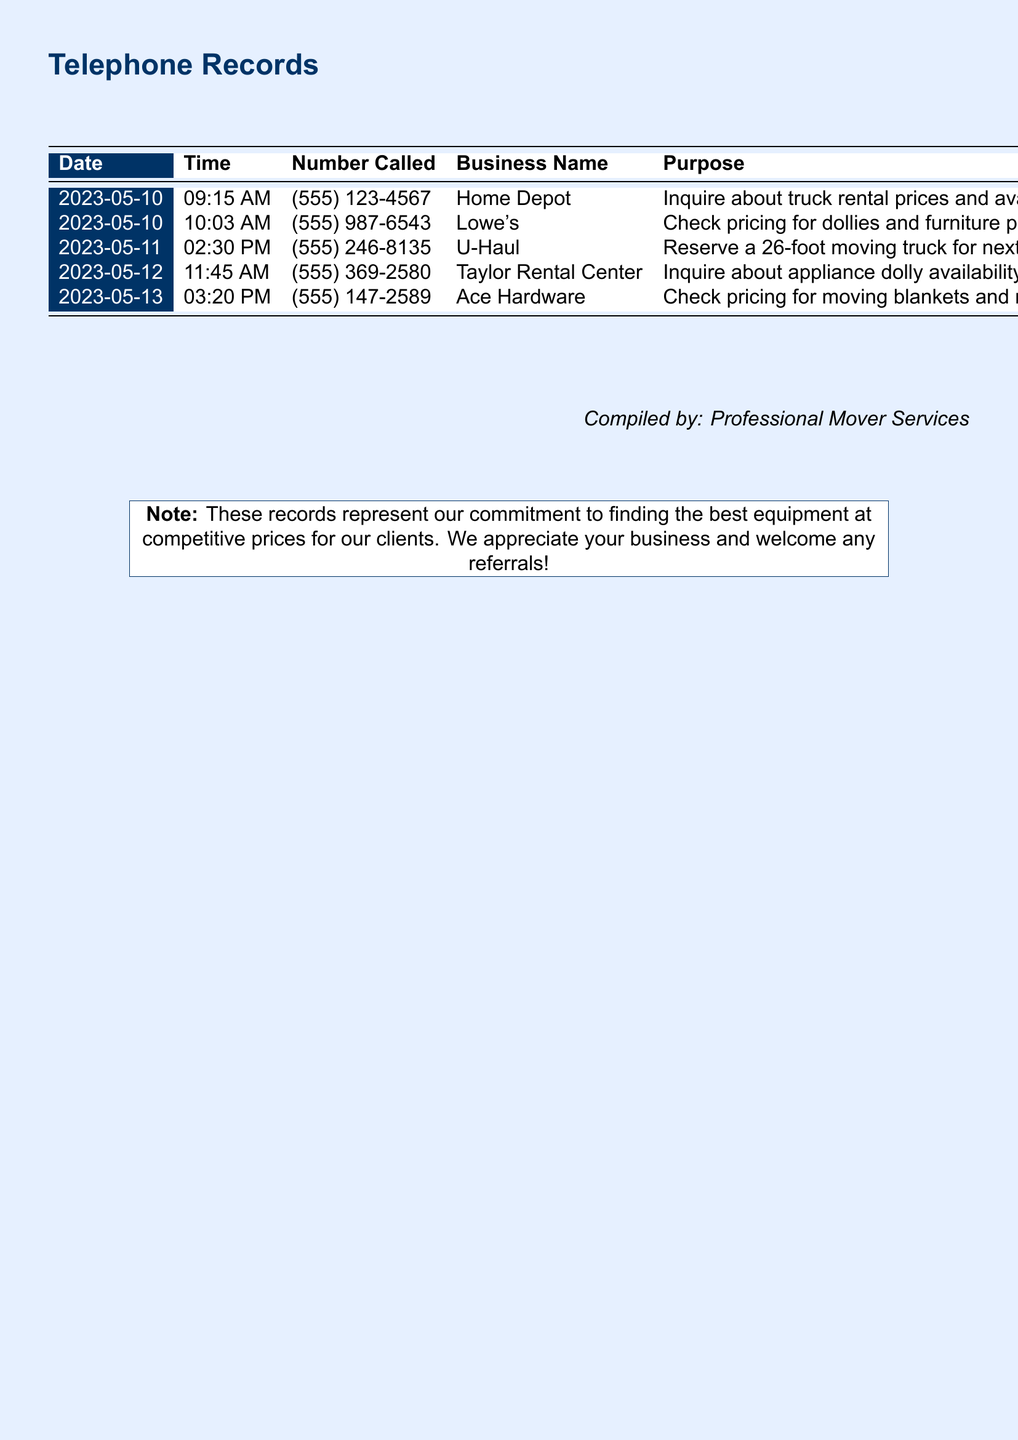What is the purpose of the call made to Home Depot? The call made to Home Depot was to inquire about truck rental prices and availability.
Answer: Inquire about truck rental prices and availability What is the duration of the call to Lowe's? The duration of the call to Lowe's was specifically recorded in the document.
Answer: 3:45 Which store was called to reserve a moving truck? The document states that U-Haul was called to reserve a 26-foot moving truck for next week.
Answer: U-Haul What date was the call to Taylor Rental Center made? The date is clearly shown in the document for each call, including the one to Taylor Rental Center.
Answer: 2023-05-12 Which equipment was checked for pricing at Ace Hardware? The equipment inquired about at Ace Hardware is specified in the document.
Answer: Moving blankets and rope How many calls were made in total according to the records? The number of calls can be determined by counting the entries in the table of the document.
Answer: 5 What time was the call to U-Haul made? The time of the call to U-Haul is noted in the document.
Answer: 02:30 PM Which business name corresponds to the number (555) 147-2589? The document links the phone number (555) 147-2589 to a specific business.
Answer: Ace Hardware 